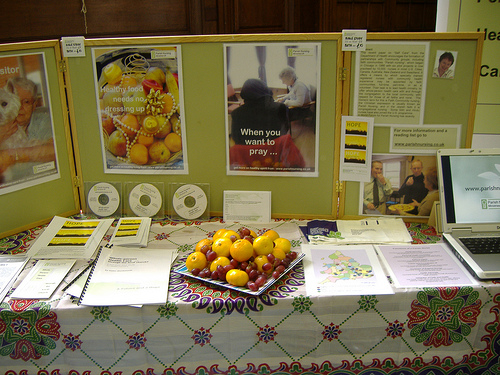<image>
Is the cd under the picture? Yes. The cd is positioned underneath the picture, with the picture above it in the vertical space. Is the orange in the book? No. The orange is not contained within the book. These objects have a different spatial relationship. 